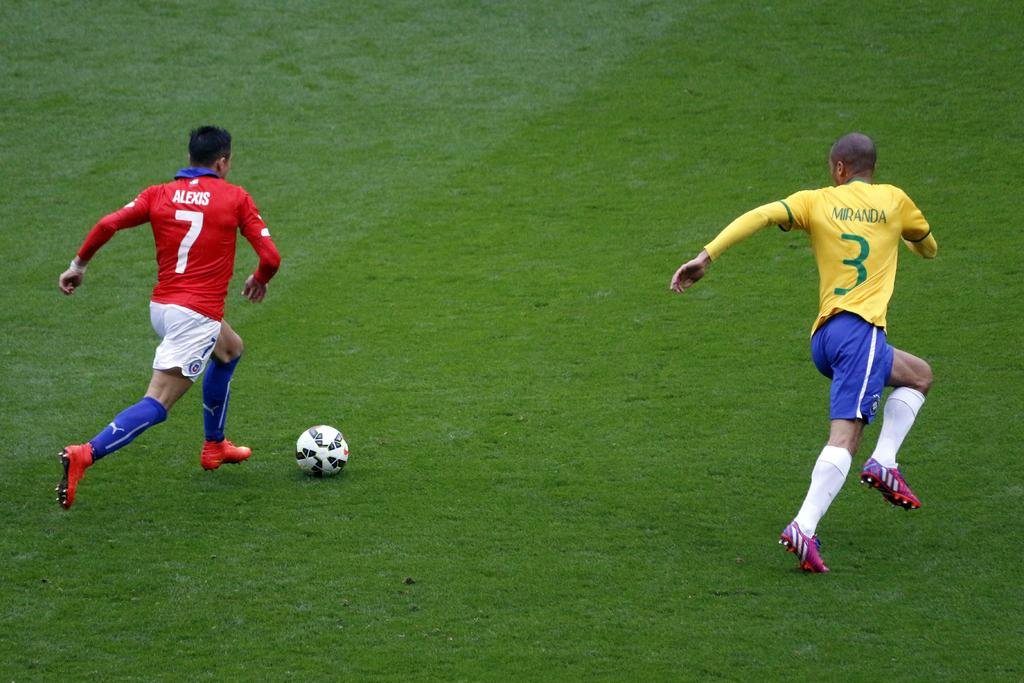<image>
Give a short and clear explanation of the subsequent image. Alexis is number 7 and Miranda is number 3. 